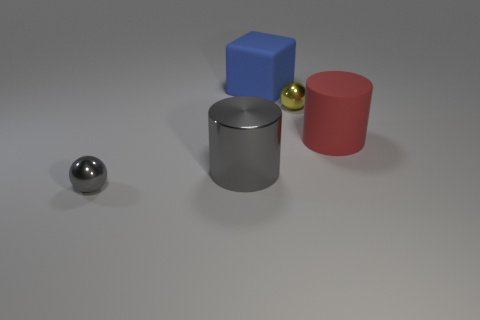There is a gray object that is the same shape as the large red rubber object; what material is it?
Keep it short and to the point. Metal. Is there anything else that is the same material as the big blue thing?
Give a very brief answer. Yes. There is a large gray metallic thing; are there any big gray things in front of it?
Your response must be concise. No. How many small gray spheres are there?
Make the answer very short. 1. How many red objects are in front of the thing in front of the gray metallic cylinder?
Provide a succinct answer. 0. Does the big matte block have the same color as the small ball that is right of the small gray thing?
Ensure brevity in your answer.  No. How many other matte objects are the same shape as the large red rubber object?
Keep it short and to the point. 0. There is a tiny sphere that is on the right side of the cube; what material is it?
Provide a short and direct response. Metal. There is a small object that is left of the big rubber cube; is it the same shape as the small yellow object?
Offer a terse response. Yes. Is there a gray cylinder that has the same size as the blue thing?
Keep it short and to the point. Yes. 